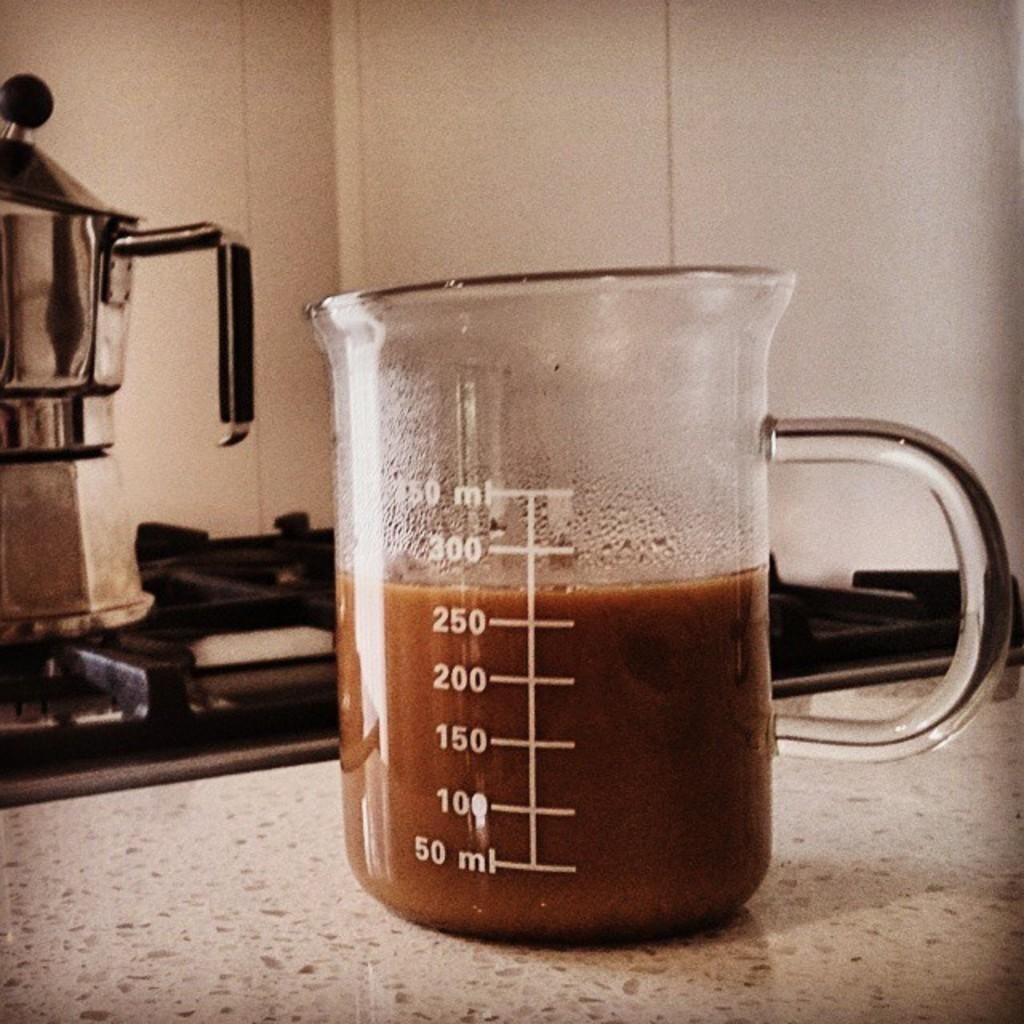Provide a one-sentence caption for the provided image. a clear glass pitcher has 275 ml of brown liquid in it. 